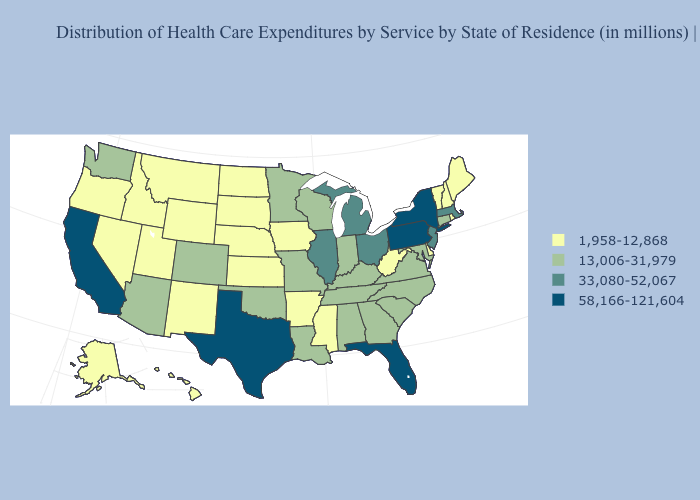Name the states that have a value in the range 1,958-12,868?
Keep it brief. Alaska, Arkansas, Delaware, Hawaii, Idaho, Iowa, Kansas, Maine, Mississippi, Montana, Nebraska, Nevada, New Hampshire, New Mexico, North Dakota, Oregon, Rhode Island, South Dakota, Utah, Vermont, West Virginia, Wyoming. Among the states that border Oklahoma , does Texas have the highest value?
Give a very brief answer. Yes. Does Rhode Island have the lowest value in the Northeast?
Concise answer only. Yes. Name the states that have a value in the range 33,080-52,067?
Write a very short answer. Illinois, Massachusetts, Michigan, New Jersey, Ohio. Which states have the lowest value in the USA?
Give a very brief answer. Alaska, Arkansas, Delaware, Hawaii, Idaho, Iowa, Kansas, Maine, Mississippi, Montana, Nebraska, Nevada, New Hampshire, New Mexico, North Dakota, Oregon, Rhode Island, South Dakota, Utah, Vermont, West Virginia, Wyoming. Which states hav the highest value in the South?
Answer briefly. Florida, Texas. Name the states that have a value in the range 13,006-31,979?
Give a very brief answer. Alabama, Arizona, Colorado, Connecticut, Georgia, Indiana, Kentucky, Louisiana, Maryland, Minnesota, Missouri, North Carolina, Oklahoma, South Carolina, Tennessee, Virginia, Washington, Wisconsin. What is the highest value in states that border Missouri?
Short answer required. 33,080-52,067. Does Illinois have the same value as Minnesota?
Write a very short answer. No. Does Texas have the highest value in the USA?
Answer briefly. Yes. Does Connecticut have a lower value than Nevada?
Quick response, please. No. What is the value of Indiana?
Quick response, please. 13,006-31,979. What is the value of Arkansas?
Give a very brief answer. 1,958-12,868. Does the map have missing data?
Concise answer only. No. What is the lowest value in the Northeast?
Be succinct. 1,958-12,868. 